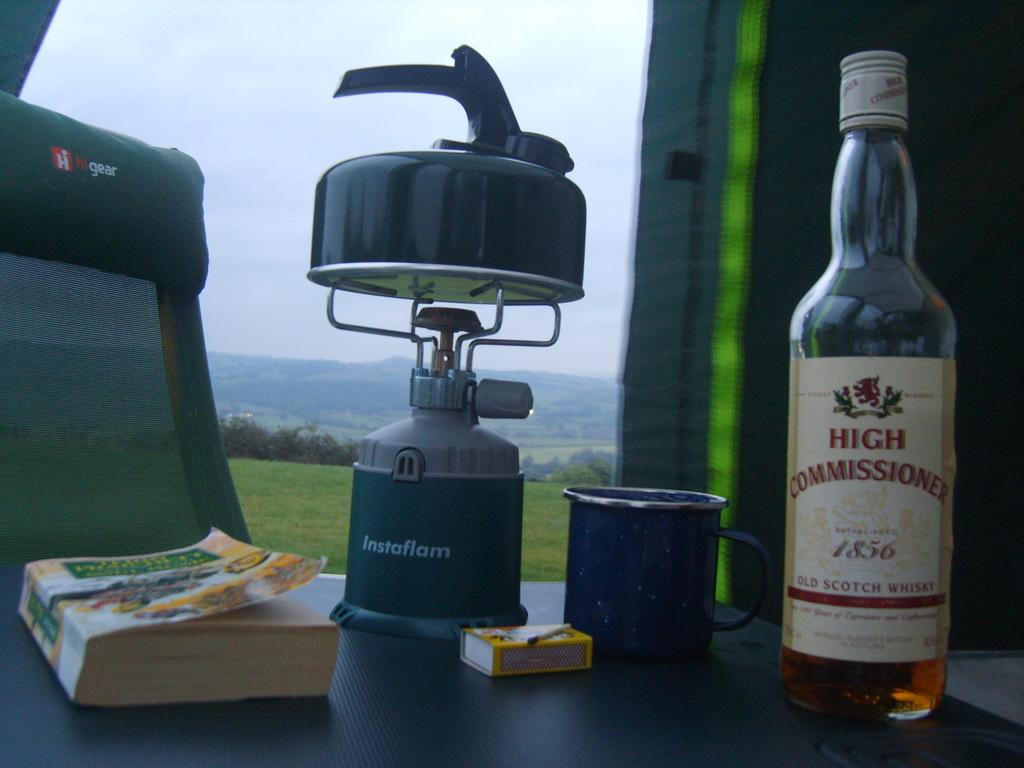<image>
Present a compact description of the photo's key features. A tea kettle is sitting on top of an unlit Instaflam camping burner. 